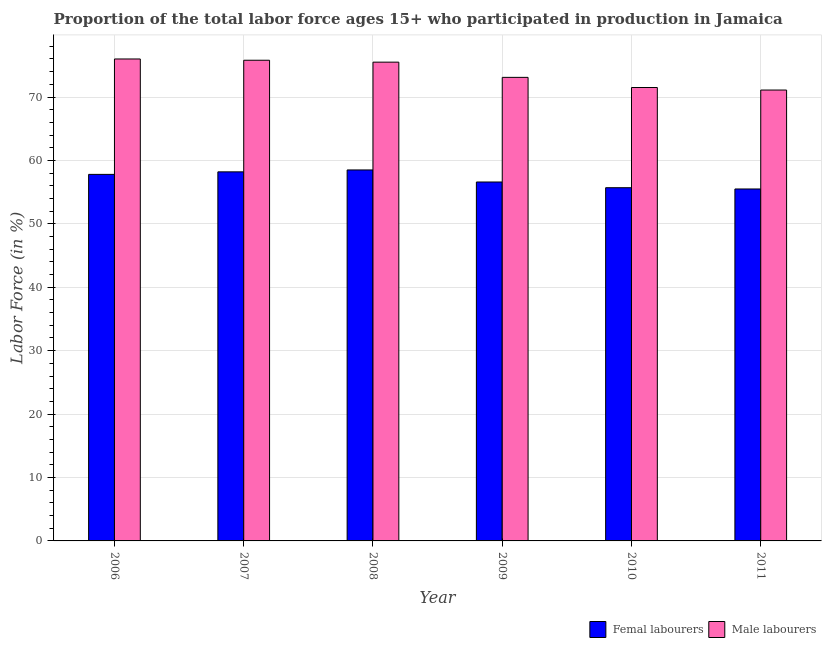How many different coloured bars are there?
Make the answer very short. 2. How many bars are there on the 4th tick from the left?
Provide a short and direct response. 2. What is the percentage of female labor force in 2010?
Ensure brevity in your answer.  55.7. Across all years, what is the maximum percentage of male labour force?
Give a very brief answer. 76. Across all years, what is the minimum percentage of female labor force?
Provide a succinct answer. 55.5. In which year was the percentage of female labor force maximum?
Give a very brief answer. 2008. In which year was the percentage of female labor force minimum?
Offer a terse response. 2011. What is the total percentage of female labor force in the graph?
Offer a terse response. 342.3. What is the difference between the percentage of female labor force in 2007 and that in 2009?
Keep it short and to the point. 1.6. What is the difference between the percentage of female labor force in 2011 and the percentage of male labour force in 2008?
Offer a very short reply. -3. What is the average percentage of male labour force per year?
Ensure brevity in your answer.  73.83. In the year 2007, what is the difference between the percentage of female labor force and percentage of male labour force?
Make the answer very short. 0. In how many years, is the percentage of female labor force greater than 16 %?
Offer a terse response. 6. What is the ratio of the percentage of male labour force in 2006 to that in 2007?
Your answer should be compact. 1. Is the percentage of female labor force in 2006 less than that in 2011?
Your answer should be very brief. No. What is the difference between the highest and the second highest percentage of female labor force?
Give a very brief answer. 0.3. What does the 1st bar from the left in 2008 represents?
Keep it short and to the point. Femal labourers. What does the 1st bar from the right in 2011 represents?
Ensure brevity in your answer.  Male labourers. How many bars are there?
Offer a very short reply. 12. Are all the bars in the graph horizontal?
Make the answer very short. No. How many years are there in the graph?
Make the answer very short. 6. What is the difference between two consecutive major ticks on the Y-axis?
Give a very brief answer. 10. Are the values on the major ticks of Y-axis written in scientific E-notation?
Give a very brief answer. No. Does the graph contain any zero values?
Ensure brevity in your answer.  No. Does the graph contain grids?
Ensure brevity in your answer.  Yes. How many legend labels are there?
Offer a terse response. 2. What is the title of the graph?
Your answer should be very brief. Proportion of the total labor force ages 15+ who participated in production in Jamaica. What is the label or title of the Y-axis?
Offer a very short reply. Labor Force (in %). What is the Labor Force (in %) in Femal labourers in 2006?
Your response must be concise. 57.8. What is the Labor Force (in %) in Male labourers in 2006?
Your response must be concise. 76. What is the Labor Force (in %) of Femal labourers in 2007?
Provide a succinct answer. 58.2. What is the Labor Force (in %) in Male labourers in 2007?
Offer a very short reply. 75.8. What is the Labor Force (in %) in Femal labourers in 2008?
Your answer should be compact. 58.5. What is the Labor Force (in %) of Male labourers in 2008?
Offer a terse response. 75.5. What is the Labor Force (in %) of Femal labourers in 2009?
Provide a short and direct response. 56.6. What is the Labor Force (in %) of Male labourers in 2009?
Keep it short and to the point. 73.1. What is the Labor Force (in %) in Femal labourers in 2010?
Your answer should be very brief. 55.7. What is the Labor Force (in %) in Male labourers in 2010?
Your response must be concise. 71.5. What is the Labor Force (in %) in Femal labourers in 2011?
Your answer should be very brief. 55.5. What is the Labor Force (in %) in Male labourers in 2011?
Offer a terse response. 71.1. Across all years, what is the maximum Labor Force (in %) of Femal labourers?
Provide a succinct answer. 58.5. Across all years, what is the maximum Labor Force (in %) of Male labourers?
Give a very brief answer. 76. Across all years, what is the minimum Labor Force (in %) in Femal labourers?
Provide a succinct answer. 55.5. Across all years, what is the minimum Labor Force (in %) of Male labourers?
Make the answer very short. 71.1. What is the total Labor Force (in %) in Femal labourers in the graph?
Your response must be concise. 342.3. What is the total Labor Force (in %) of Male labourers in the graph?
Keep it short and to the point. 443. What is the difference between the Labor Force (in %) in Male labourers in 2006 and that in 2007?
Your response must be concise. 0.2. What is the difference between the Labor Force (in %) of Male labourers in 2006 and that in 2008?
Your response must be concise. 0.5. What is the difference between the Labor Force (in %) in Femal labourers in 2006 and that in 2009?
Make the answer very short. 1.2. What is the difference between the Labor Force (in %) in Male labourers in 2006 and that in 2009?
Ensure brevity in your answer.  2.9. What is the difference between the Labor Force (in %) of Femal labourers in 2006 and that in 2010?
Your answer should be compact. 2.1. What is the difference between the Labor Force (in %) of Femal labourers in 2006 and that in 2011?
Your response must be concise. 2.3. What is the difference between the Labor Force (in %) in Male labourers in 2006 and that in 2011?
Your answer should be very brief. 4.9. What is the difference between the Labor Force (in %) of Male labourers in 2007 and that in 2008?
Provide a succinct answer. 0.3. What is the difference between the Labor Force (in %) of Femal labourers in 2007 and that in 2011?
Provide a short and direct response. 2.7. What is the difference between the Labor Force (in %) of Male labourers in 2008 and that in 2009?
Provide a succinct answer. 2.4. What is the difference between the Labor Force (in %) of Femal labourers in 2009 and that in 2010?
Offer a very short reply. 0.9. What is the difference between the Labor Force (in %) in Femal labourers in 2006 and the Labor Force (in %) in Male labourers in 2008?
Give a very brief answer. -17.7. What is the difference between the Labor Force (in %) of Femal labourers in 2006 and the Labor Force (in %) of Male labourers in 2009?
Give a very brief answer. -15.3. What is the difference between the Labor Force (in %) in Femal labourers in 2006 and the Labor Force (in %) in Male labourers in 2010?
Offer a very short reply. -13.7. What is the difference between the Labor Force (in %) of Femal labourers in 2006 and the Labor Force (in %) of Male labourers in 2011?
Provide a short and direct response. -13.3. What is the difference between the Labor Force (in %) in Femal labourers in 2007 and the Labor Force (in %) in Male labourers in 2008?
Give a very brief answer. -17.3. What is the difference between the Labor Force (in %) of Femal labourers in 2007 and the Labor Force (in %) of Male labourers in 2009?
Your answer should be very brief. -14.9. What is the difference between the Labor Force (in %) of Femal labourers in 2007 and the Labor Force (in %) of Male labourers in 2010?
Make the answer very short. -13.3. What is the difference between the Labor Force (in %) of Femal labourers in 2007 and the Labor Force (in %) of Male labourers in 2011?
Your answer should be compact. -12.9. What is the difference between the Labor Force (in %) in Femal labourers in 2008 and the Labor Force (in %) in Male labourers in 2009?
Your answer should be compact. -14.6. What is the difference between the Labor Force (in %) of Femal labourers in 2008 and the Labor Force (in %) of Male labourers in 2010?
Your answer should be compact. -13. What is the difference between the Labor Force (in %) of Femal labourers in 2009 and the Labor Force (in %) of Male labourers in 2010?
Make the answer very short. -14.9. What is the difference between the Labor Force (in %) of Femal labourers in 2010 and the Labor Force (in %) of Male labourers in 2011?
Offer a terse response. -15.4. What is the average Labor Force (in %) of Femal labourers per year?
Offer a terse response. 57.05. What is the average Labor Force (in %) in Male labourers per year?
Your response must be concise. 73.83. In the year 2006, what is the difference between the Labor Force (in %) of Femal labourers and Labor Force (in %) of Male labourers?
Give a very brief answer. -18.2. In the year 2007, what is the difference between the Labor Force (in %) in Femal labourers and Labor Force (in %) in Male labourers?
Provide a succinct answer. -17.6. In the year 2008, what is the difference between the Labor Force (in %) of Femal labourers and Labor Force (in %) of Male labourers?
Make the answer very short. -17. In the year 2009, what is the difference between the Labor Force (in %) in Femal labourers and Labor Force (in %) in Male labourers?
Ensure brevity in your answer.  -16.5. In the year 2010, what is the difference between the Labor Force (in %) in Femal labourers and Labor Force (in %) in Male labourers?
Ensure brevity in your answer.  -15.8. In the year 2011, what is the difference between the Labor Force (in %) in Femal labourers and Labor Force (in %) in Male labourers?
Ensure brevity in your answer.  -15.6. What is the ratio of the Labor Force (in %) of Male labourers in 2006 to that in 2007?
Your answer should be very brief. 1. What is the ratio of the Labor Force (in %) in Male labourers in 2006 to that in 2008?
Provide a succinct answer. 1.01. What is the ratio of the Labor Force (in %) in Femal labourers in 2006 to that in 2009?
Keep it short and to the point. 1.02. What is the ratio of the Labor Force (in %) in Male labourers in 2006 to that in 2009?
Your answer should be very brief. 1.04. What is the ratio of the Labor Force (in %) of Femal labourers in 2006 to that in 2010?
Your answer should be very brief. 1.04. What is the ratio of the Labor Force (in %) of Male labourers in 2006 to that in 2010?
Your response must be concise. 1.06. What is the ratio of the Labor Force (in %) in Femal labourers in 2006 to that in 2011?
Your answer should be very brief. 1.04. What is the ratio of the Labor Force (in %) of Male labourers in 2006 to that in 2011?
Your answer should be very brief. 1.07. What is the ratio of the Labor Force (in %) of Femal labourers in 2007 to that in 2009?
Your answer should be compact. 1.03. What is the ratio of the Labor Force (in %) of Male labourers in 2007 to that in 2009?
Ensure brevity in your answer.  1.04. What is the ratio of the Labor Force (in %) in Femal labourers in 2007 to that in 2010?
Offer a very short reply. 1.04. What is the ratio of the Labor Force (in %) of Male labourers in 2007 to that in 2010?
Offer a terse response. 1.06. What is the ratio of the Labor Force (in %) of Femal labourers in 2007 to that in 2011?
Provide a succinct answer. 1.05. What is the ratio of the Labor Force (in %) of Male labourers in 2007 to that in 2011?
Offer a very short reply. 1.07. What is the ratio of the Labor Force (in %) in Femal labourers in 2008 to that in 2009?
Provide a succinct answer. 1.03. What is the ratio of the Labor Force (in %) of Male labourers in 2008 to that in 2009?
Your answer should be compact. 1.03. What is the ratio of the Labor Force (in %) in Femal labourers in 2008 to that in 2010?
Give a very brief answer. 1.05. What is the ratio of the Labor Force (in %) of Male labourers in 2008 to that in 2010?
Offer a terse response. 1.06. What is the ratio of the Labor Force (in %) of Femal labourers in 2008 to that in 2011?
Your response must be concise. 1.05. What is the ratio of the Labor Force (in %) in Male labourers in 2008 to that in 2011?
Your answer should be very brief. 1.06. What is the ratio of the Labor Force (in %) of Femal labourers in 2009 to that in 2010?
Offer a very short reply. 1.02. What is the ratio of the Labor Force (in %) in Male labourers in 2009 to that in 2010?
Make the answer very short. 1.02. What is the ratio of the Labor Force (in %) in Femal labourers in 2009 to that in 2011?
Offer a terse response. 1.02. What is the ratio of the Labor Force (in %) in Male labourers in 2009 to that in 2011?
Provide a short and direct response. 1.03. What is the ratio of the Labor Force (in %) in Femal labourers in 2010 to that in 2011?
Your answer should be compact. 1. What is the ratio of the Labor Force (in %) in Male labourers in 2010 to that in 2011?
Provide a succinct answer. 1.01. What is the difference between the highest and the second highest Labor Force (in %) of Femal labourers?
Your answer should be compact. 0.3. What is the difference between the highest and the lowest Labor Force (in %) of Femal labourers?
Make the answer very short. 3. What is the difference between the highest and the lowest Labor Force (in %) of Male labourers?
Give a very brief answer. 4.9. 